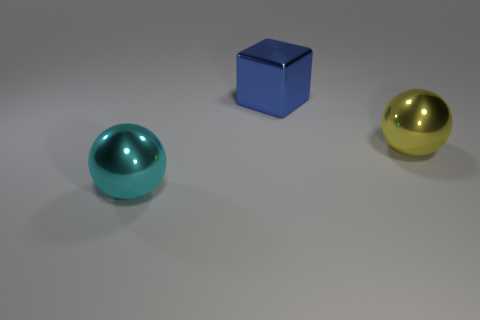Is the number of large cyan metal balls behind the cyan thing the same as the number of large metallic cubes?
Give a very brief answer. No. What number of other blue blocks are the same size as the cube?
Offer a terse response. 0. What number of metal objects are either large blue blocks or small purple spheres?
Ensure brevity in your answer.  1. How many objects are either big yellow things or big shiny spheres that are right of the large block?
Make the answer very short. 1. How many red things are either big metallic cubes or spheres?
Your response must be concise. 0. Is the shape of the big metallic thing that is on the left side of the big block the same as the object that is behind the big yellow thing?
Ensure brevity in your answer.  No. What number of small yellow shiny blocks are there?
Keep it short and to the point. 0. The big cyan object that is the same material as the yellow ball is what shape?
Your answer should be compact. Sphere. Is the number of metal cubes that are behind the large cyan thing less than the number of cyan metal objects?
Your answer should be very brief. No. How many other objects are the same size as the yellow sphere?
Make the answer very short. 2. 